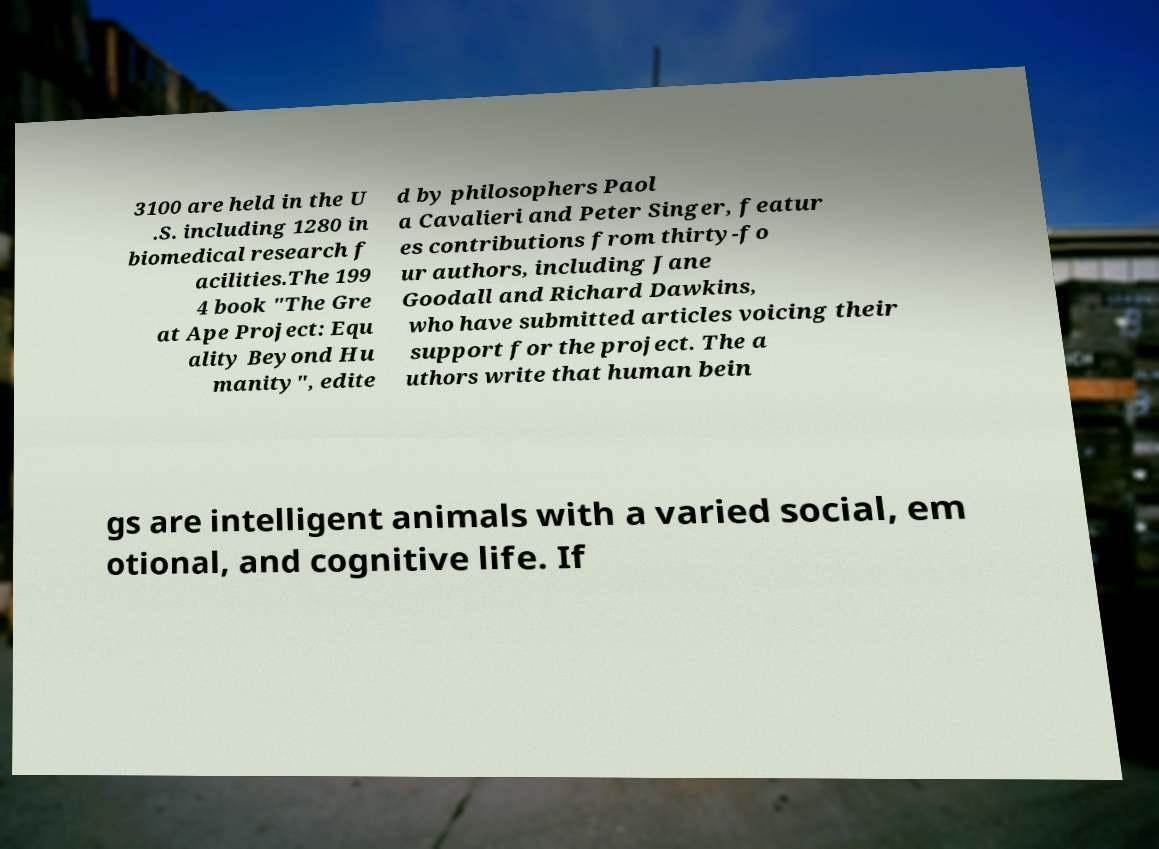Can you read and provide the text displayed in the image?This photo seems to have some interesting text. Can you extract and type it out for me? 3100 are held in the U .S. including 1280 in biomedical research f acilities.The 199 4 book "The Gre at Ape Project: Equ ality Beyond Hu manity", edite d by philosophers Paol a Cavalieri and Peter Singer, featur es contributions from thirty-fo ur authors, including Jane Goodall and Richard Dawkins, who have submitted articles voicing their support for the project. The a uthors write that human bein gs are intelligent animals with a varied social, em otional, and cognitive life. If 